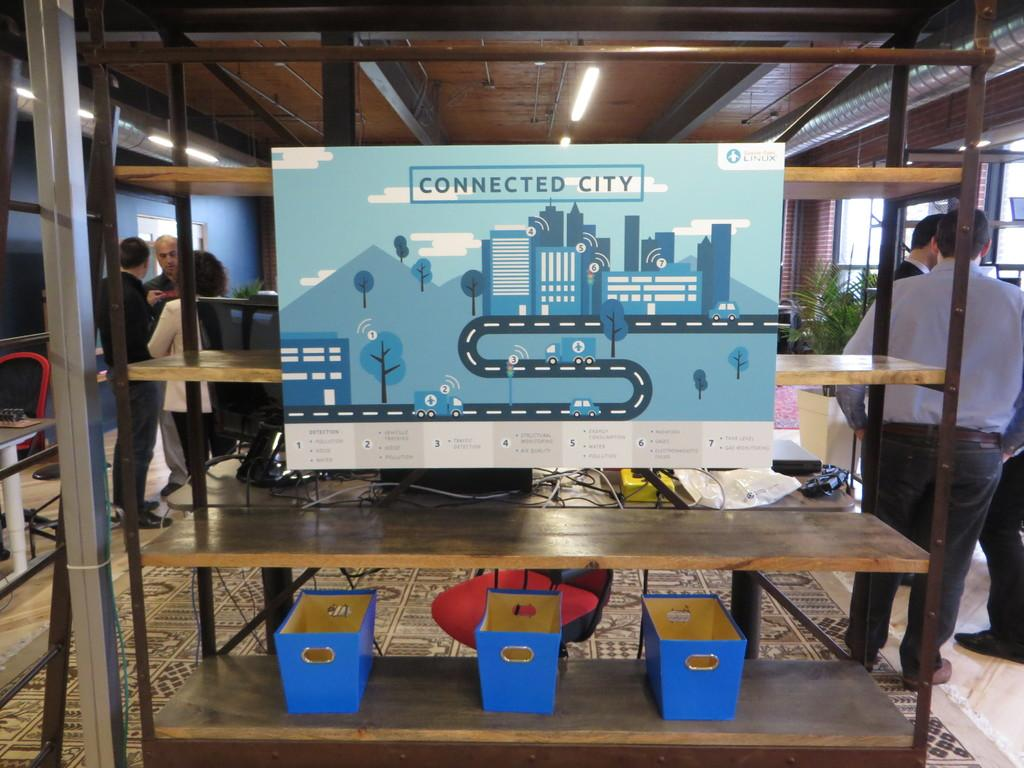What is depicted on the sheet in the image? There is a sheet with connected city written on it. Can you describe the people in the background of the image? There is a group of people in the background. What type of fiction is the minister reading in the image? There is no minister or fiction present in the image. 